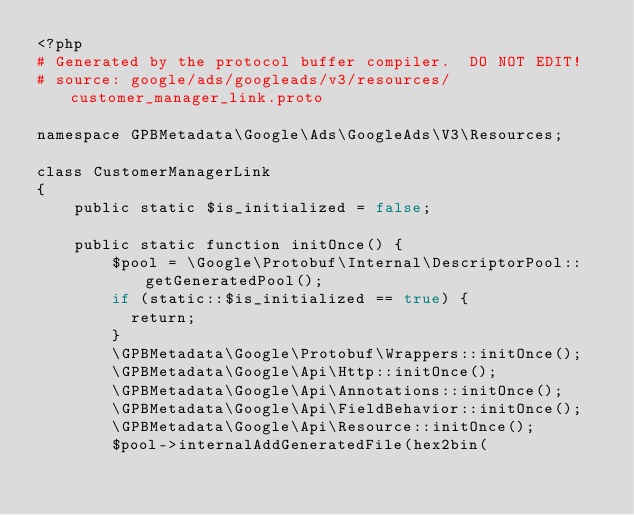<code> <loc_0><loc_0><loc_500><loc_500><_PHP_><?php
# Generated by the protocol buffer compiler.  DO NOT EDIT!
# source: google/ads/googleads/v3/resources/customer_manager_link.proto

namespace GPBMetadata\Google\Ads\GoogleAds\V3\Resources;

class CustomerManagerLink
{
    public static $is_initialized = false;

    public static function initOnce() {
        $pool = \Google\Protobuf\Internal\DescriptorPool::getGeneratedPool();
        if (static::$is_initialized == true) {
          return;
        }
        \GPBMetadata\Google\Protobuf\Wrappers::initOnce();
        \GPBMetadata\Google\Api\Http::initOnce();
        \GPBMetadata\Google\Api\Annotations::initOnce();
        \GPBMetadata\Google\Api\FieldBehavior::initOnce();
        \GPBMetadata\Google\Api\Resource::initOnce();
        $pool->internalAddGeneratedFile(hex2bin(</code> 